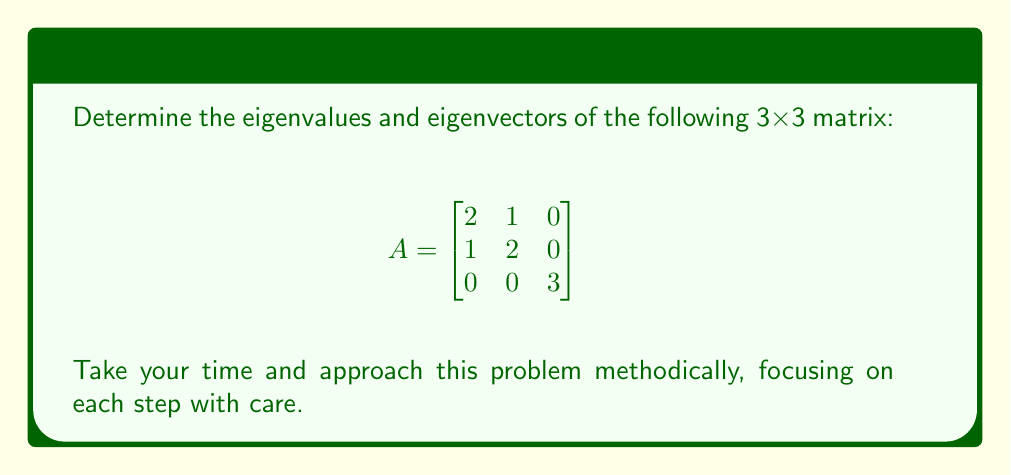Could you help me with this problem? Let's approach this problem step-by-step:

1) To find the eigenvalues, we need to solve the characteristic equation:
   $\det(A - \lambda I) = 0$

2) Let's expand this:
   $$\det\begin{bmatrix}
   2-\lambda & 1 & 0 \\
   1 & 2-\lambda & 0 \\
   0 & 0 & 3-\lambda
   \end{bmatrix} = 0$$

3) Calculating the determinant:
   $((2-\lambda)(2-\lambda) - 1)(3-\lambda) = 0$

4) Simplify:
   $(4-4\lambda+\lambda^2 - 1)(3-\lambda) = 0$
   $(\lambda^2-4\lambda+3)(3-\lambda) = 0$

5) Factor:
   $(\lambda-1)(\lambda-3)(3-\lambda) = 0$

6) Solve for $\lambda$:
   $\lambda = 1, 3, 3$

7) Now, for each eigenvalue, we find the corresponding eigenvector $\vec{v}$ by solving $(A-\lambda I)\vec{v} = \vec{0}$

8) For $\lambda_1 = 1$:
   $$\begin{bmatrix}
   1 & 1 & 0 \\
   1 & 1 & 0 \\
   0 & 0 & 2
   \end{bmatrix}\begin{bmatrix}
   v_1 \\ v_2 \\ v_3
   \end{bmatrix} = \begin{bmatrix}
   0 \\ 0 \\ 0
   \end{bmatrix}$$
   
   This gives us: $v_1 = -v_2$, $v_3 = 0$
   An eigenvector is $\vec{v_1} = \begin{bmatrix} 1 \\ -1 \\ 0 \end{bmatrix}$

9) For $\lambda_2 = \lambda_3 = 3$:
   $$\begin{bmatrix}
   -1 & 1 & 0 \\
   1 & -1 & 0 \\
   0 & 0 & 0
   \end{bmatrix}\begin{bmatrix}
   v_1 \\ v_2 \\ v_3
   \end{bmatrix} = \begin{bmatrix}
   0 \\ 0 \\ 0
   \end{bmatrix}$$
   
   This gives us: $v_1 = v_2$, $v_3$ is free
   Two linearly independent eigenvectors are:
   $\vec{v_2} = \begin{bmatrix} 1 \\ 1 \\ 0 \end{bmatrix}$ and 
   $\vec{v_3} = \begin{bmatrix} 0 \\ 0 \\ 1 \end{bmatrix}$
Answer: Eigenvalues: $\lambda_1 = 1$, $\lambda_2 = \lambda_3 = 3$
Eigenvectors: $\vec{v_1} = \begin{bmatrix} 1 \\ -1 \\ 0 \end{bmatrix}$, $\vec{v_2} = \begin{bmatrix} 1 \\ 1 \\ 0 \end{bmatrix}$, $\vec{v_3} = \begin{bmatrix} 0 \\ 0 \\ 1 \end{bmatrix}$ 